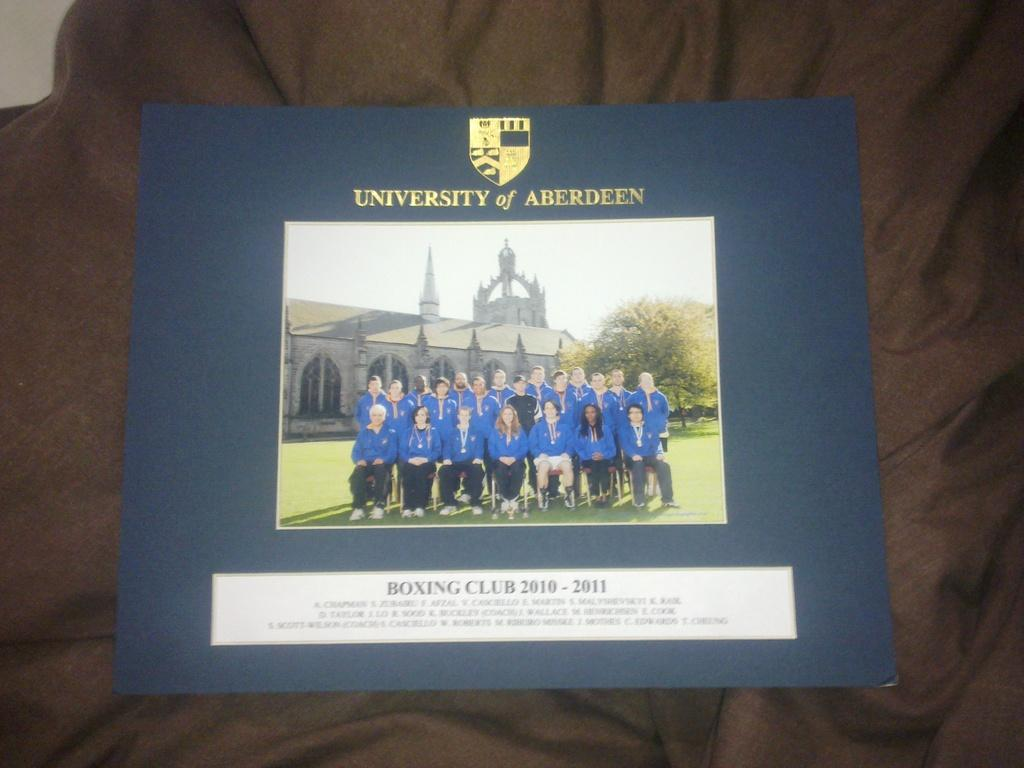<image>
Render a clear and concise summary of the photo. A photo of the University of Aberdeen's Boxing Club mounted on blue paper. 